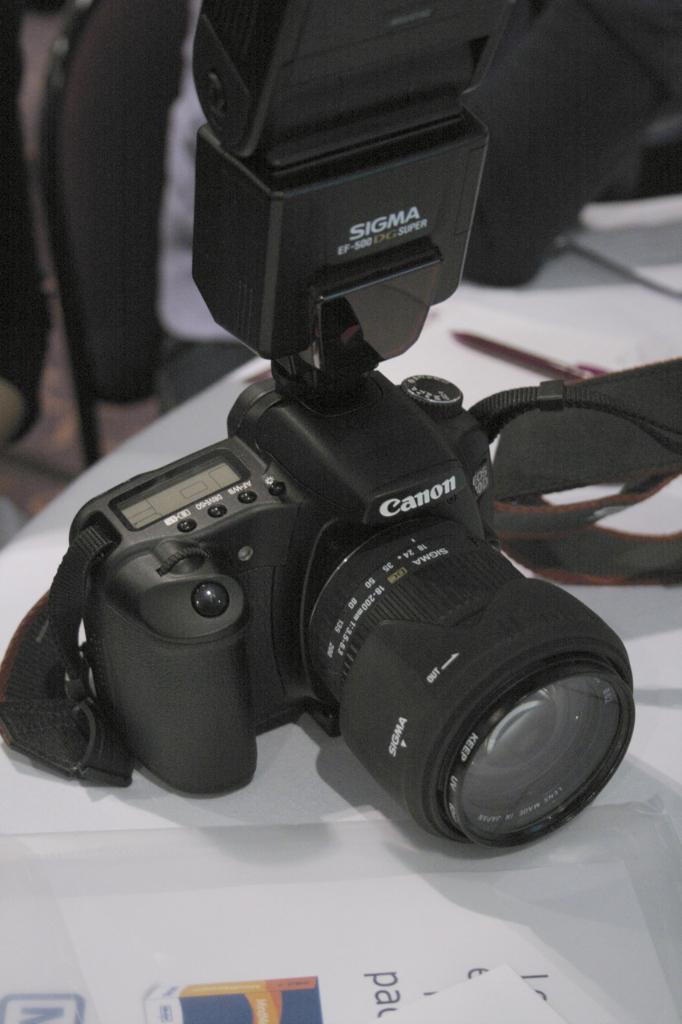In one or two sentences, can you explain what this image depicts? Here I can see a camera which is placed on the table and also there is a white color paper. The background is blurred. 